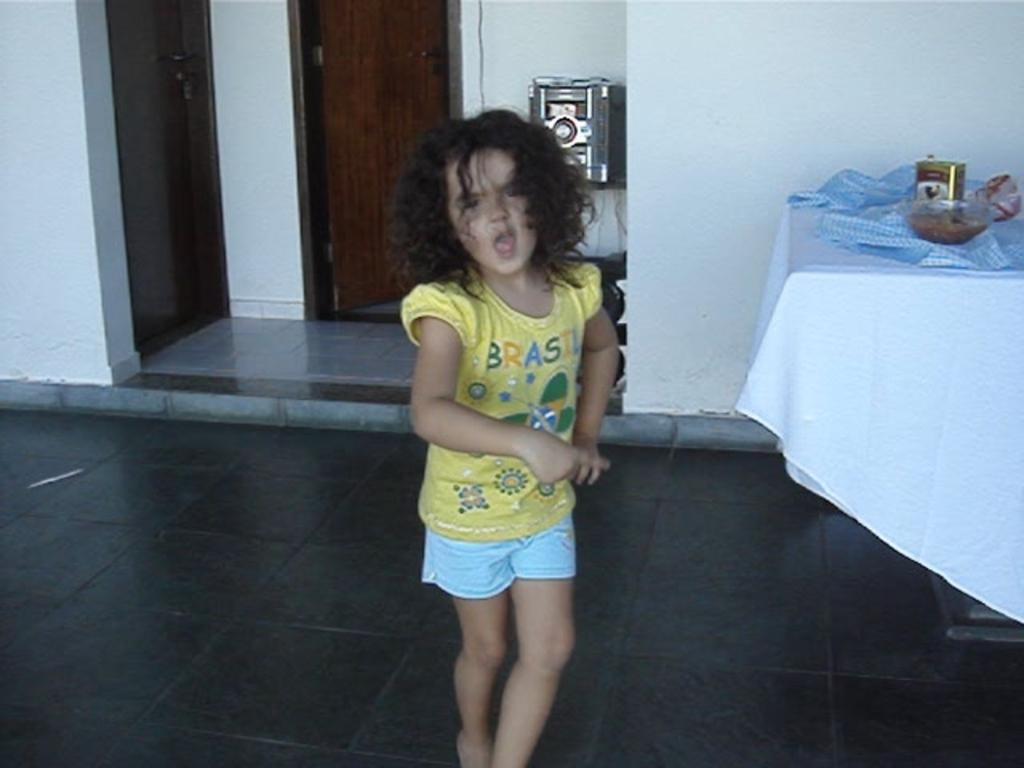Who is the main subject in the image? There is a girl in the image. What is on the table in the image? There is a bowl on a table in the image, along with other things. Can you describe the other items on the table? Unfortunately, the facts provided do not specify the other items on the table. What can be seen in the background of the image? There is a music system in the background of the image. What is the girl doing with her elbow in the image? There is no mention of the girl's elbow or any specific action involving it in the image. 